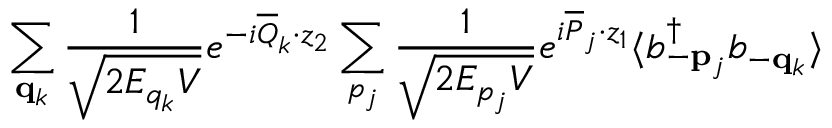Convert formula to latex. <formula><loc_0><loc_0><loc_500><loc_500>\sum _ { { q } _ { k } } \frac { 1 } { \sqrt { 2 E _ { q _ { k } } V } } e ^ { - i \overline { Q } _ { k } \cdot z _ { 2 } } \sum _ { p _ { j } } \frac { 1 } { \sqrt { 2 E _ { p _ { j } } V } } e ^ { i \overline { P } _ { j } \cdot z _ { 1 } } \langle b _ { - { p } _ { j } } ^ { \dagger } b _ { - { q } _ { k } } \rangle</formula> 